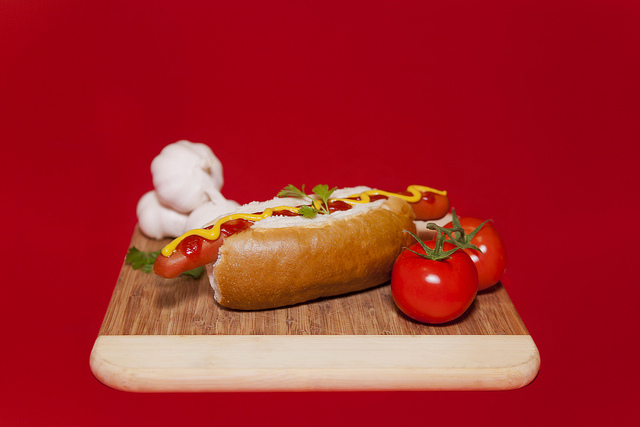What color is the table top? The tabletop in the background of the image is a striking red. 